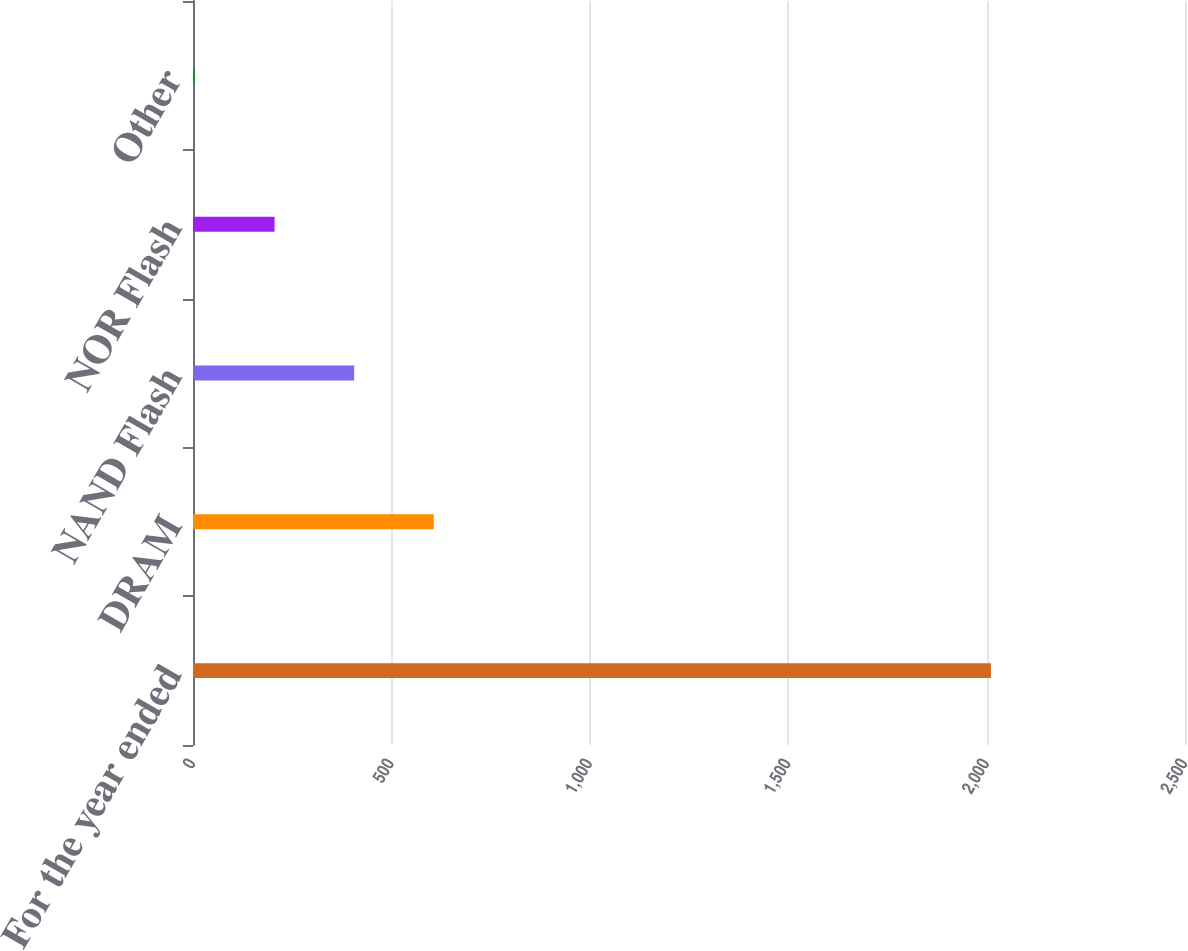Convert chart to OTSL. <chart><loc_0><loc_0><loc_500><loc_500><bar_chart><fcel>For the year ended<fcel>DRAM<fcel>NAND Flash<fcel>NOR Flash<fcel>Other<nl><fcel>2011<fcel>606.8<fcel>406.2<fcel>205.6<fcel>5<nl></chart> 